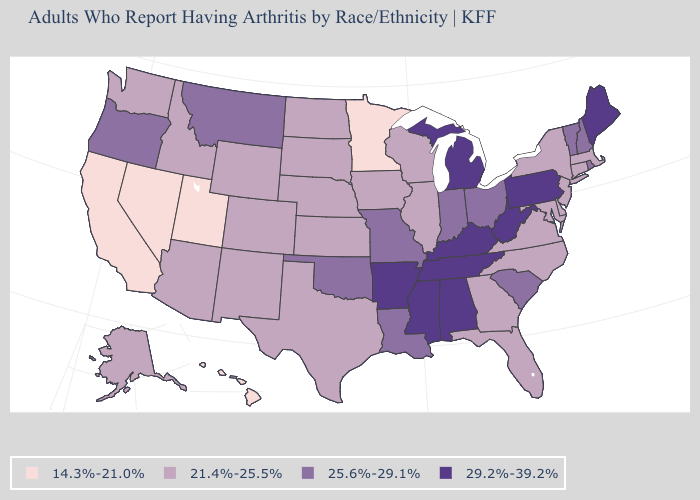Which states have the lowest value in the USA?
Concise answer only. California, Hawaii, Minnesota, Nevada, Utah. Does the first symbol in the legend represent the smallest category?
Concise answer only. Yes. Name the states that have a value in the range 14.3%-21.0%?
Answer briefly. California, Hawaii, Minnesota, Nevada, Utah. How many symbols are there in the legend?
Keep it brief. 4. Is the legend a continuous bar?
Be succinct. No. Among the states that border Virginia , does North Carolina have the highest value?
Be succinct. No. Does Rhode Island have a lower value than Mississippi?
Be succinct. Yes. What is the value of Colorado?
Short answer required. 21.4%-25.5%. Name the states that have a value in the range 29.2%-39.2%?
Short answer required. Alabama, Arkansas, Kentucky, Maine, Michigan, Mississippi, Pennsylvania, Tennessee, West Virginia. Which states hav the highest value in the MidWest?
Concise answer only. Michigan. Does Delaware have the same value as Mississippi?
Write a very short answer. No. What is the highest value in states that border Illinois?
Be succinct. 29.2%-39.2%. Which states have the lowest value in the South?
Answer briefly. Delaware, Florida, Georgia, Maryland, North Carolina, Texas, Virginia. Name the states that have a value in the range 29.2%-39.2%?
Answer briefly. Alabama, Arkansas, Kentucky, Maine, Michigan, Mississippi, Pennsylvania, Tennessee, West Virginia. What is the value of California?
Short answer required. 14.3%-21.0%. 